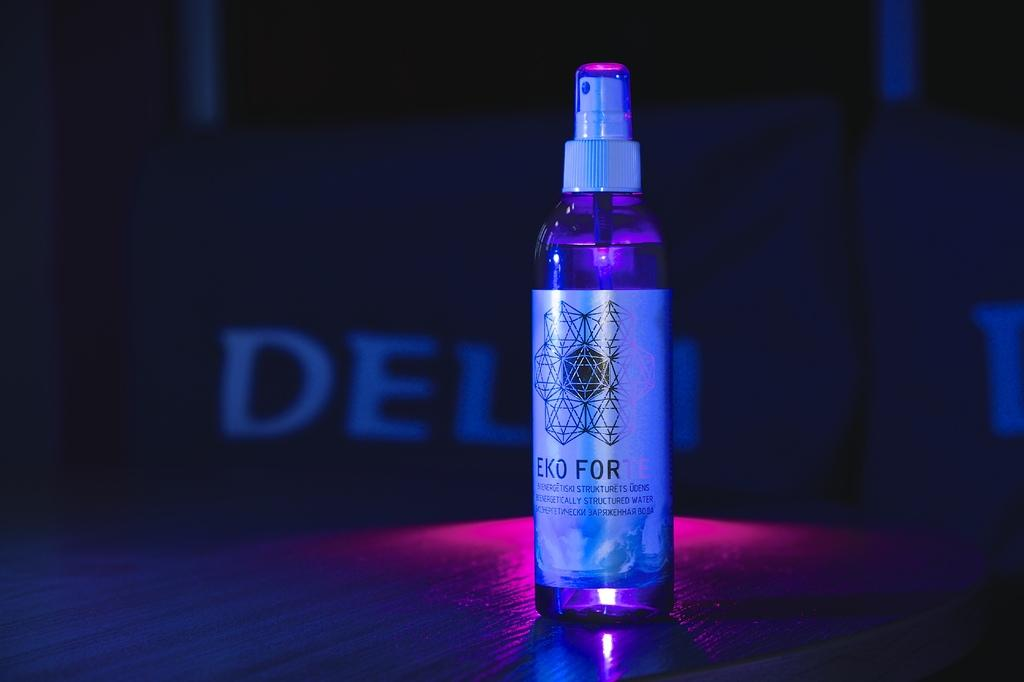Provide a one-sentence caption for the provided image. A bottle with a spray top being displayed in dim lighting with label Eco For. 